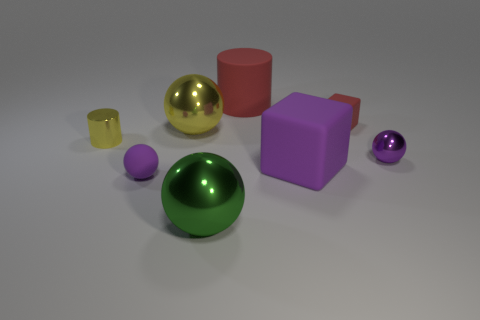What number of things are large green metallic things or small purple metal spheres?
Give a very brief answer. 2. The large thing that is both behind the big purple thing and right of the big green sphere has what shape?
Your answer should be very brief. Cylinder. Is the shape of the tiny purple metal object the same as the tiny purple object that is to the left of the large yellow thing?
Make the answer very short. Yes. There is a small cube; are there any small yellow things to the right of it?
Keep it short and to the point. No. There is a large ball that is the same color as the metal cylinder; what is its material?
Your answer should be compact. Metal. What number of spheres are big blue things or tiny purple metal things?
Offer a very short reply. 1. Do the green shiny object and the small yellow object have the same shape?
Provide a succinct answer. No. There is a purple rubber thing that is right of the big red matte thing; what size is it?
Keep it short and to the point. Large. Is there a metallic sphere of the same color as the metallic cylinder?
Your answer should be compact. Yes. There is a purple matte object that is on the left side of the red matte cylinder; is its size the same as the large red cylinder?
Your answer should be very brief. No. 